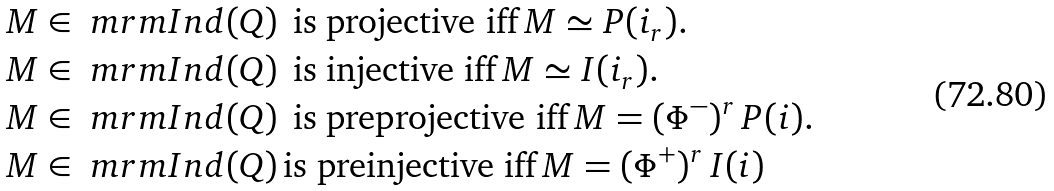Convert formula to latex. <formula><loc_0><loc_0><loc_500><loc_500>& M \in \ m r m { I n d } ( Q ) \, \text { is projective iff} \, M \simeq P ( i _ { r } ) . \\ & M \in \ m r m { I n d } ( Q ) \, \text { is injective iff} \, M \simeq I ( i _ { r } ) . \\ & M \in \ m r m { I n d } ( Q ) \, \text { is preprojective iff} \, M = ( \Phi ^ { - } ) ^ { r } \, P ( i ) . \\ & M \in \ m r m { I n d } ( Q ) \, \text {is preinjective iff} \, M = ( \Phi ^ { + } ) ^ { r } \, I ( i )</formula> 